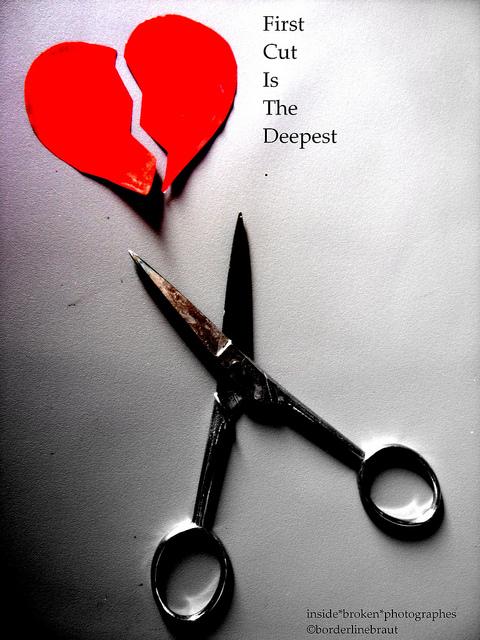What is the metal object?
Short answer required. Scissors. Is the heartbroken?
Give a very brief answer. Yes. Is the scissors open or closed?
Be succinct. Open. What has cut into this heart?
Quick response, please. Scissors. 